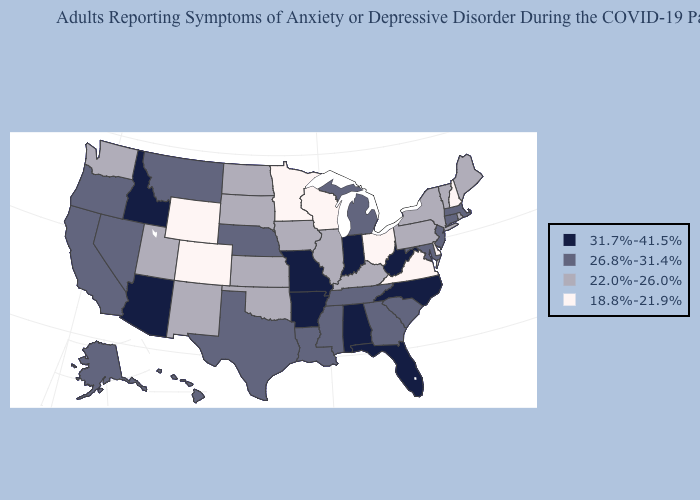Among the states that border Ohio , which have the highest value?
Quick response, please. Indiana, West Virginia. What is the lowest value in the USA?
Concise answer only. 18.8%-21.9%. Does Nevada have a lower value than Florida?
Give a very brief answer. Yes. Does North Carolina have the highest value in the South?
Answer briefly. Yes. How many symbols are there in the legend?
Answer briefly. 4. Name the states that have a value in the range 18.8%-21.9%?
Keep it brief. Colorado, Delaware, Minnesota, New Hampshire, Ohio, Virginia, Wisconsin, Wyoming. Among the states that border Iowa , does Nebraska have the lowest value?
Concise answer only. No. Does Michigan have a higher value than Ohio?
Keep it brief. Yes. What is the value of Florida?
Answer briefly. 31.7%-41.5%. Name the states that have a value in the range 26.8%-31.4%?
Write a very short answer. Alaska, California, Connecticut, Georgia, Hawaii, Louisiana, Maryland, Massachusetts, Michigan, Mississippi, Montana, Nebraska, Nevada, New Jersey, Oregon, South Carolina, Tennessee, Texas. Name the states that have a value in the range 22.0%-26.0%?
Keep it brief. Illinois, Iowa, Kansas, Kentucky, Maine, New Mexico, New York, North Dakota, Oklahoma, Pennsylvania, Rhode Island, South Dakota, Utah, Vermont, Washington. Among the states that border Michigan , does Ohio have the highest value?
Quick response, please. No. Is the legend a continuous bar?
Write a very short answer. No. Does Tennessee have a lower value than Iowa?
Short answer required. No. Among the states that border Nevada , does Oregon have the lowest value?
Concise answer only. No. 